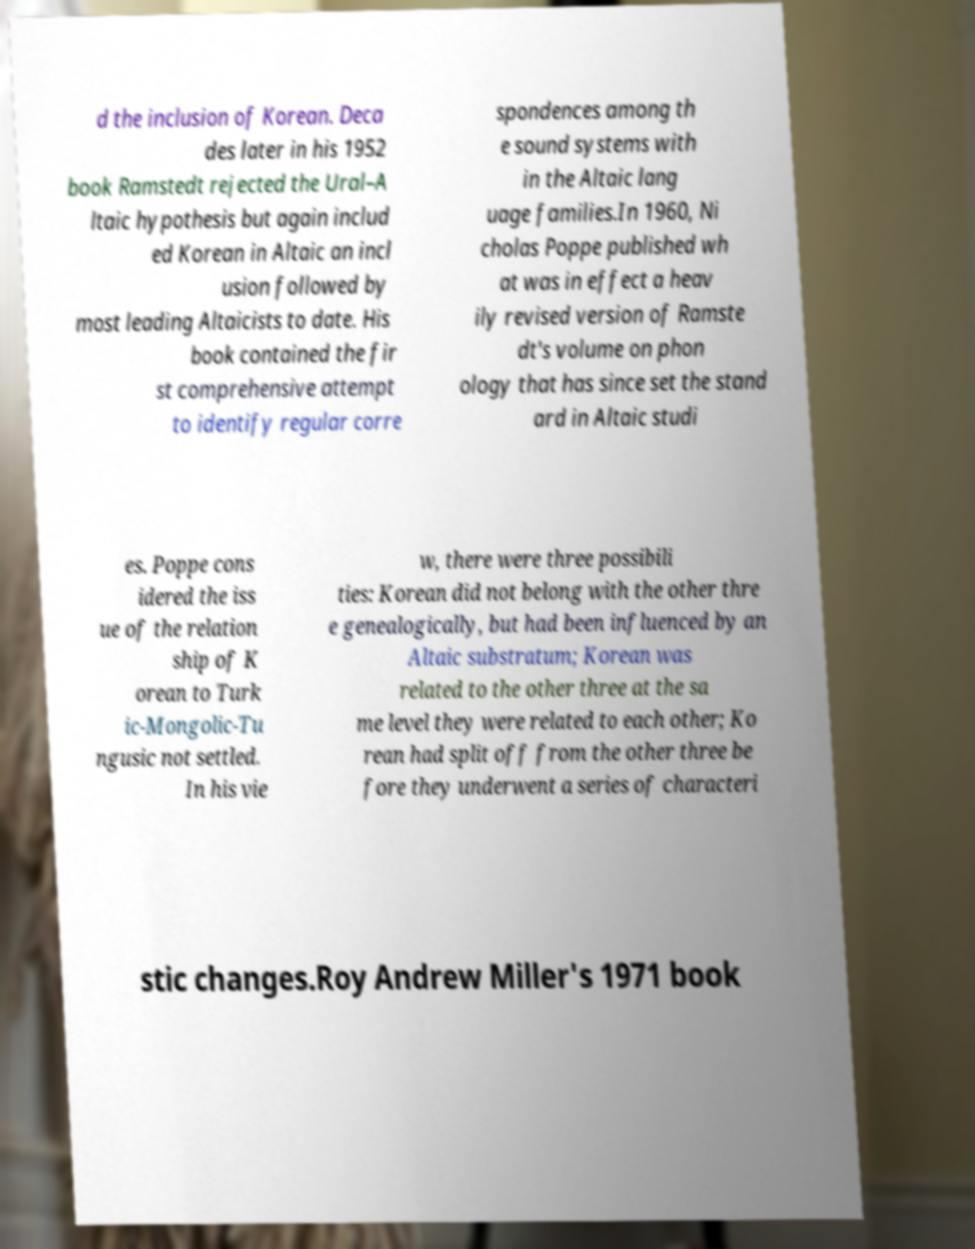I need the written content from this picture converted into text. Can you do that? d the inclusion of Korean. Deca des later in his 1952 book Ramstedt rejected the Ural–A ltaic hypothesis but again includ ed Korean in Altaic an incl usion followed by most leading Altaicists to date. His book contained the fir st comprehensive attempt to identify regular corre spondences among th e sound systems with in the Altaic lang uage families.In 1960, Ni cholas Poppe published wh at was in effect a heav ily revised version of Ramste dt's volume on phon ology that has since set the stand ard in Altaic studi es. Poppe cons idered the iss ue of the relation ship of K orean to Turk ic-Mongolic-Tu ngusic not settled. In his vie w, there were three possibili ties: Korean did not belong with the other thre e genealogically, but had been influenced by an Altaic substratum; Korean was related to the other three at the sa me level they were related to each other; Ko rean had split off from the other three be fore they underwent a series of characteri stic changes.Roy Andrew Miller's 1971 book 